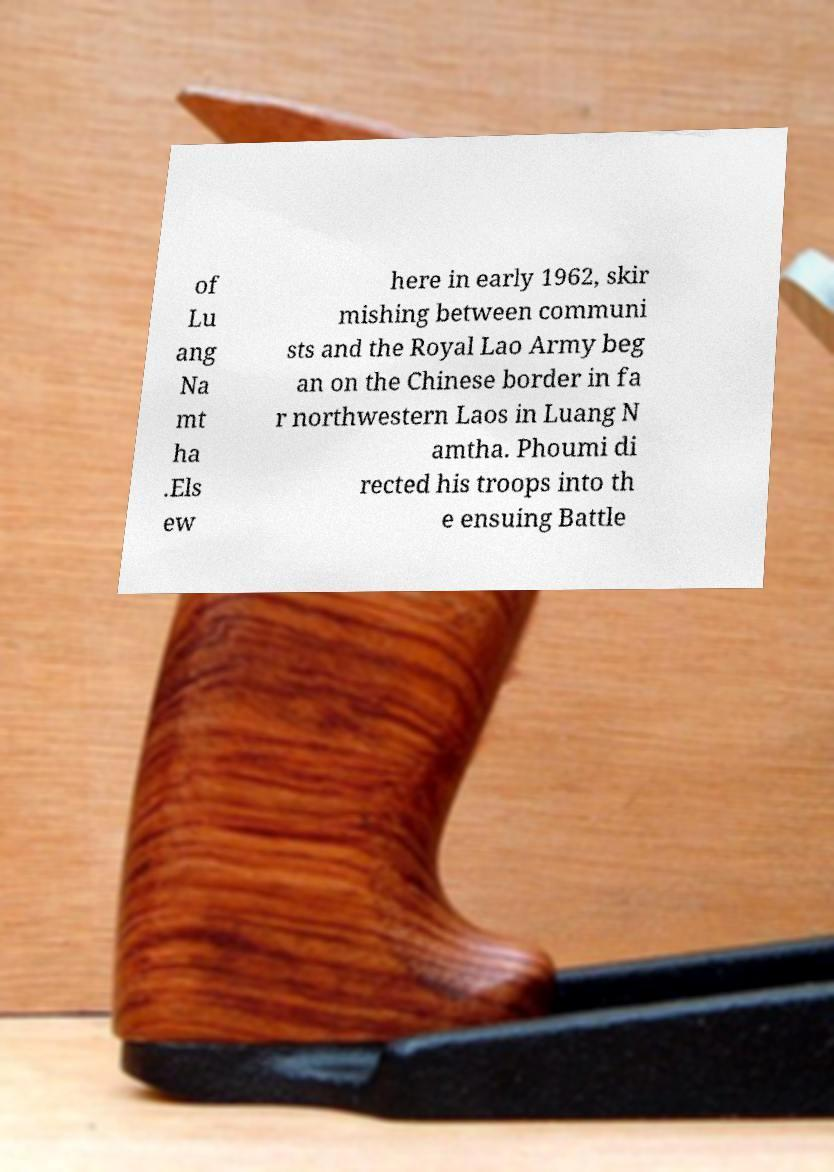Could you assist in decoding the text presented in this image and type it out clearly? of Lu ang Na mt ha .Els ew here in early 1962, skir mishing between communi sts and the Royal Lao Army beg an on the Chinese border in fa r northwestern Laos in Luang N amtha. Phoumi di rected his troops into th e ensuing Battle 